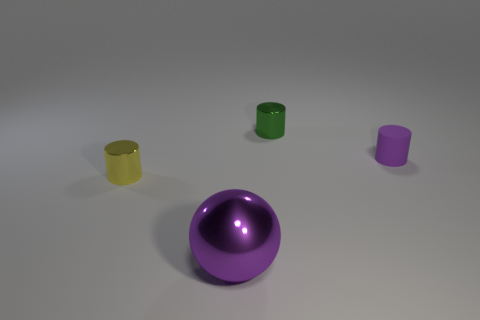Add 3 purple rubber objects. How many objects exist? 7 Subtract all balls. How many objects are left? 3 Subtract all green metallic objects. Subtract all small yellow metal objects. How many objects are left? 2 Add 3 big things. How many big things are left? 4 Add 3 small green cylinders. How many small green cylinders exist? 4 Subtract 0 purple blocks. How many objects are left? 4 